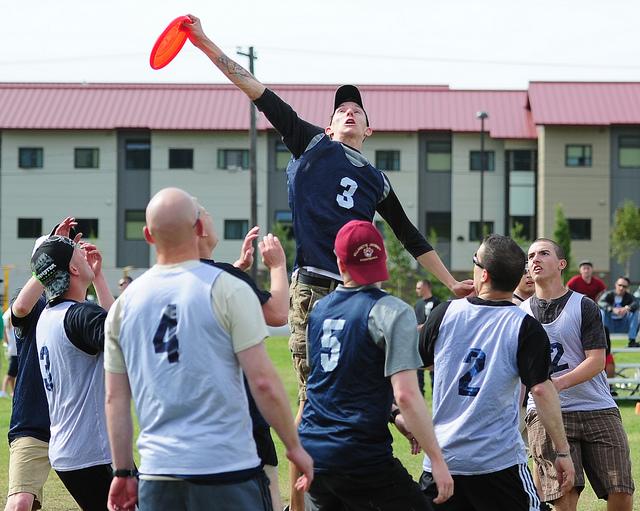What that guy holding?
Write a very short answer. Frisbee. Which of these people seem least happy?
Give a very brief answer. Guy on right. How many are wearing glasses?
Quick response, please. 1. What sport is this?
Concise answer only. Frisbee. Is this a professional sport?
Keep it brief. No. Does it look like this team is winning or losing?
Give a very brief answer. Winning. What is the number of the player holding the frisbee?
Be succinct. 3. What is the man holding?
Keep it brief. Frisbee. What is the difference between the two teams?
Write a very short answer. Uniform colors. 